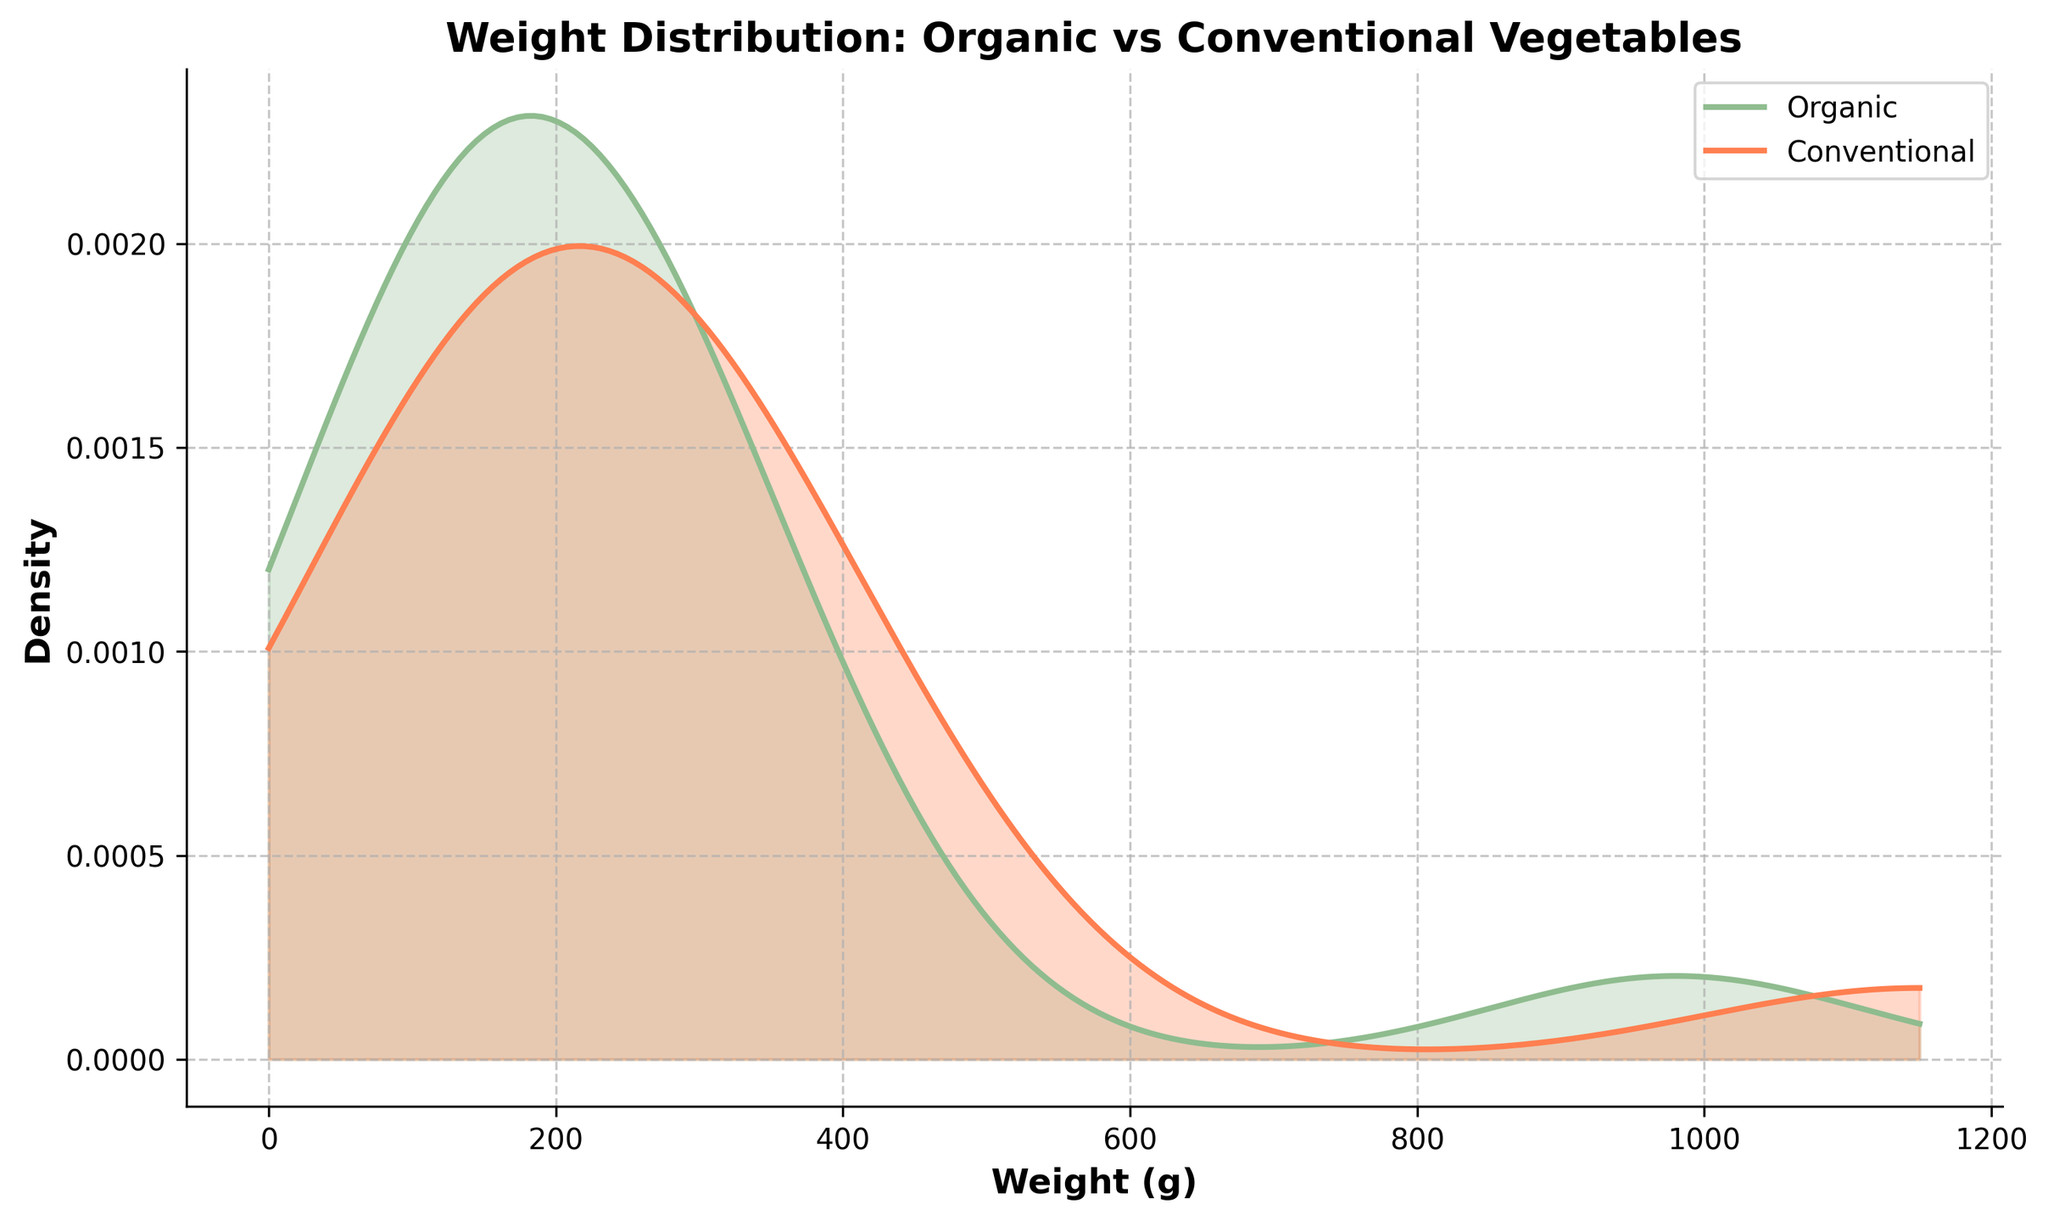What are the two categories compared in the figure? The figure title "Weight Distribution: Organic vs Conventional Vegetables" and the legend indicate two categories: Organic and Conventional.
Answer: Organic and Conventional What color represents the weight distribution of organic vegetables? The legend shows the color distribution of organic vegetables in light green.
Answer: Light green Which type of weight has the highest density peak? By looking at the density curves, the conventional weight (represented in light coral color) has the highest peak.
Answer: Conventional weight What is the approximate weight range where both distributions have density peaks? Both density curves show peaks between around 200g and 400g for both types of vegetables.
Answer: 200g and 400g How are the density curves labeled? The legend of the plot indicates the labels for the density curves; Organic and Conventional.
Answer: Organic and Conventional What is the purpose of the different fill colors under the curves? The different fill colors make it easier to see and compare the areas under the curves for Organic (green) and Conventional (coral).
Answer: To compare areas under the curves Which category has a wider range of weights with significant density? Observing the width of the curves, the Conventional category has a wider weight range with significant density extending beyond 1000g.
Answer: Conventional Is there any overlapping weight range with density values for both distributions? There is an overlapping weight range, mainly between 0g and 400g, where both curves show density values.
Answer: Yes Are the distributions skewed in any particular direction? The Organic distribution appears more normally distributed around a central weight, while the Conventional distribution shows a slight rightward skew with higher density at larger weights.
Answer: Organic is more centered, Conventional is right-skewed 